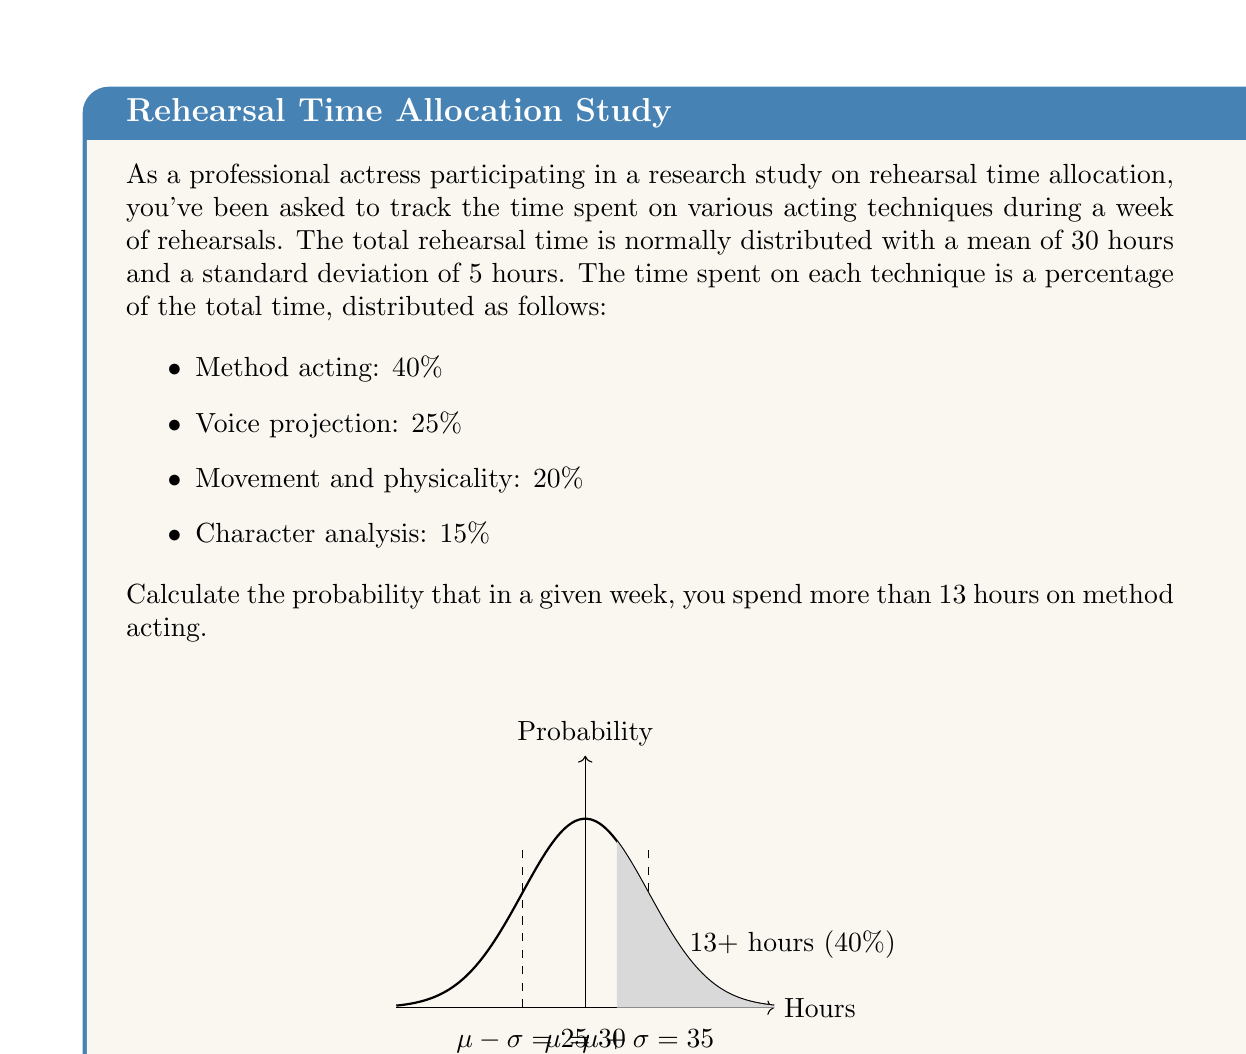What is the answer to this math problem? Let's approach this step-by-step:

1) First, we need to determine the number of hours that corresponds to 13 hours of method acting. Since method acting takes up 40% of the total time, we can set up the equation:

   $13 = 0.40x$, where $x$ is the total rehearsal time

2) Solving for $x$:
   $x = 13 / 0.40 = 32.5$ hours

3) Now, we need to find the probability that the total rehearsal time exceeds 32.5 hours. We can use the z-score formula:

   $z = \frac{x - \mu}{\sigma}$

   Where $x = 32.5$, $\mu = 30$, and $\sigma = 5$

4) Calculating the z-score:

   $z = \frac{32.5 - 30}{5} = 0.5$

5) To find the probability, we need to look up the area to the right of z = 0.5 in a standard normal table, or use a calculator/computer function.

6) The area to the right of z = 0.5 is approximately 0.3085.

Therefore, the probability of spending more than 13 hours on method acting in a given week is about 0.3085 or 30.85%.
Answer: $$P(X > 13) \approx 0.3085$$ 